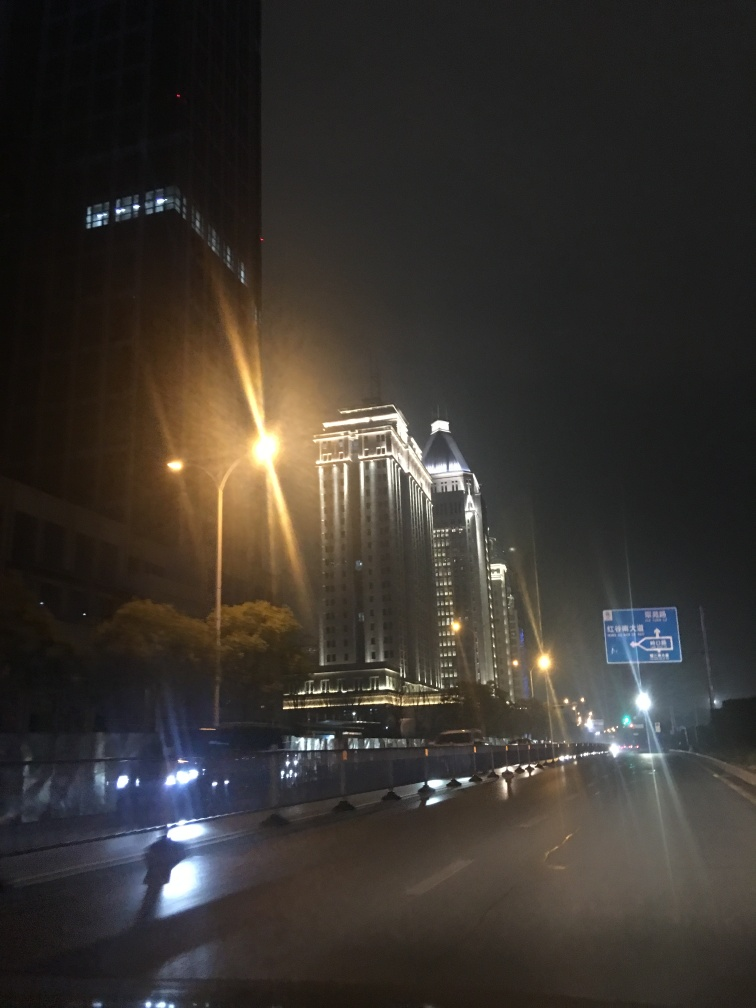What does this image depict?
A. City skyline
B. Highway scenery
C. Beach view
Answer with the option's letter from the given choices directly.
 B. 